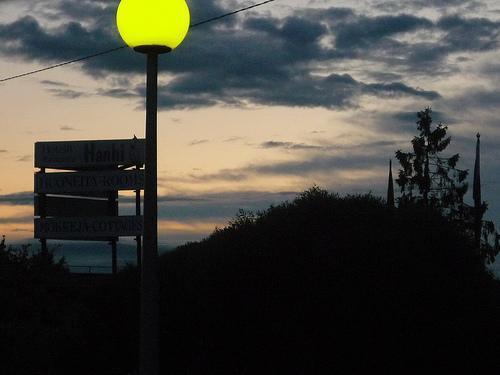How many lights are there?
Give a very brief answer. 1. 